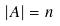<formula> <loc_0><loc_0><loc_500><loc_500>| A | = n</formula> 